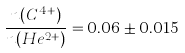<formula> <loc_0><loc_0><loc_500><loc_500>\frac { n ( C ^ { 4 + } ) } { n ( H e ^ { 2 + } ) } = 0 . 0 6 \pm 0 . 0 1 5</formula> 